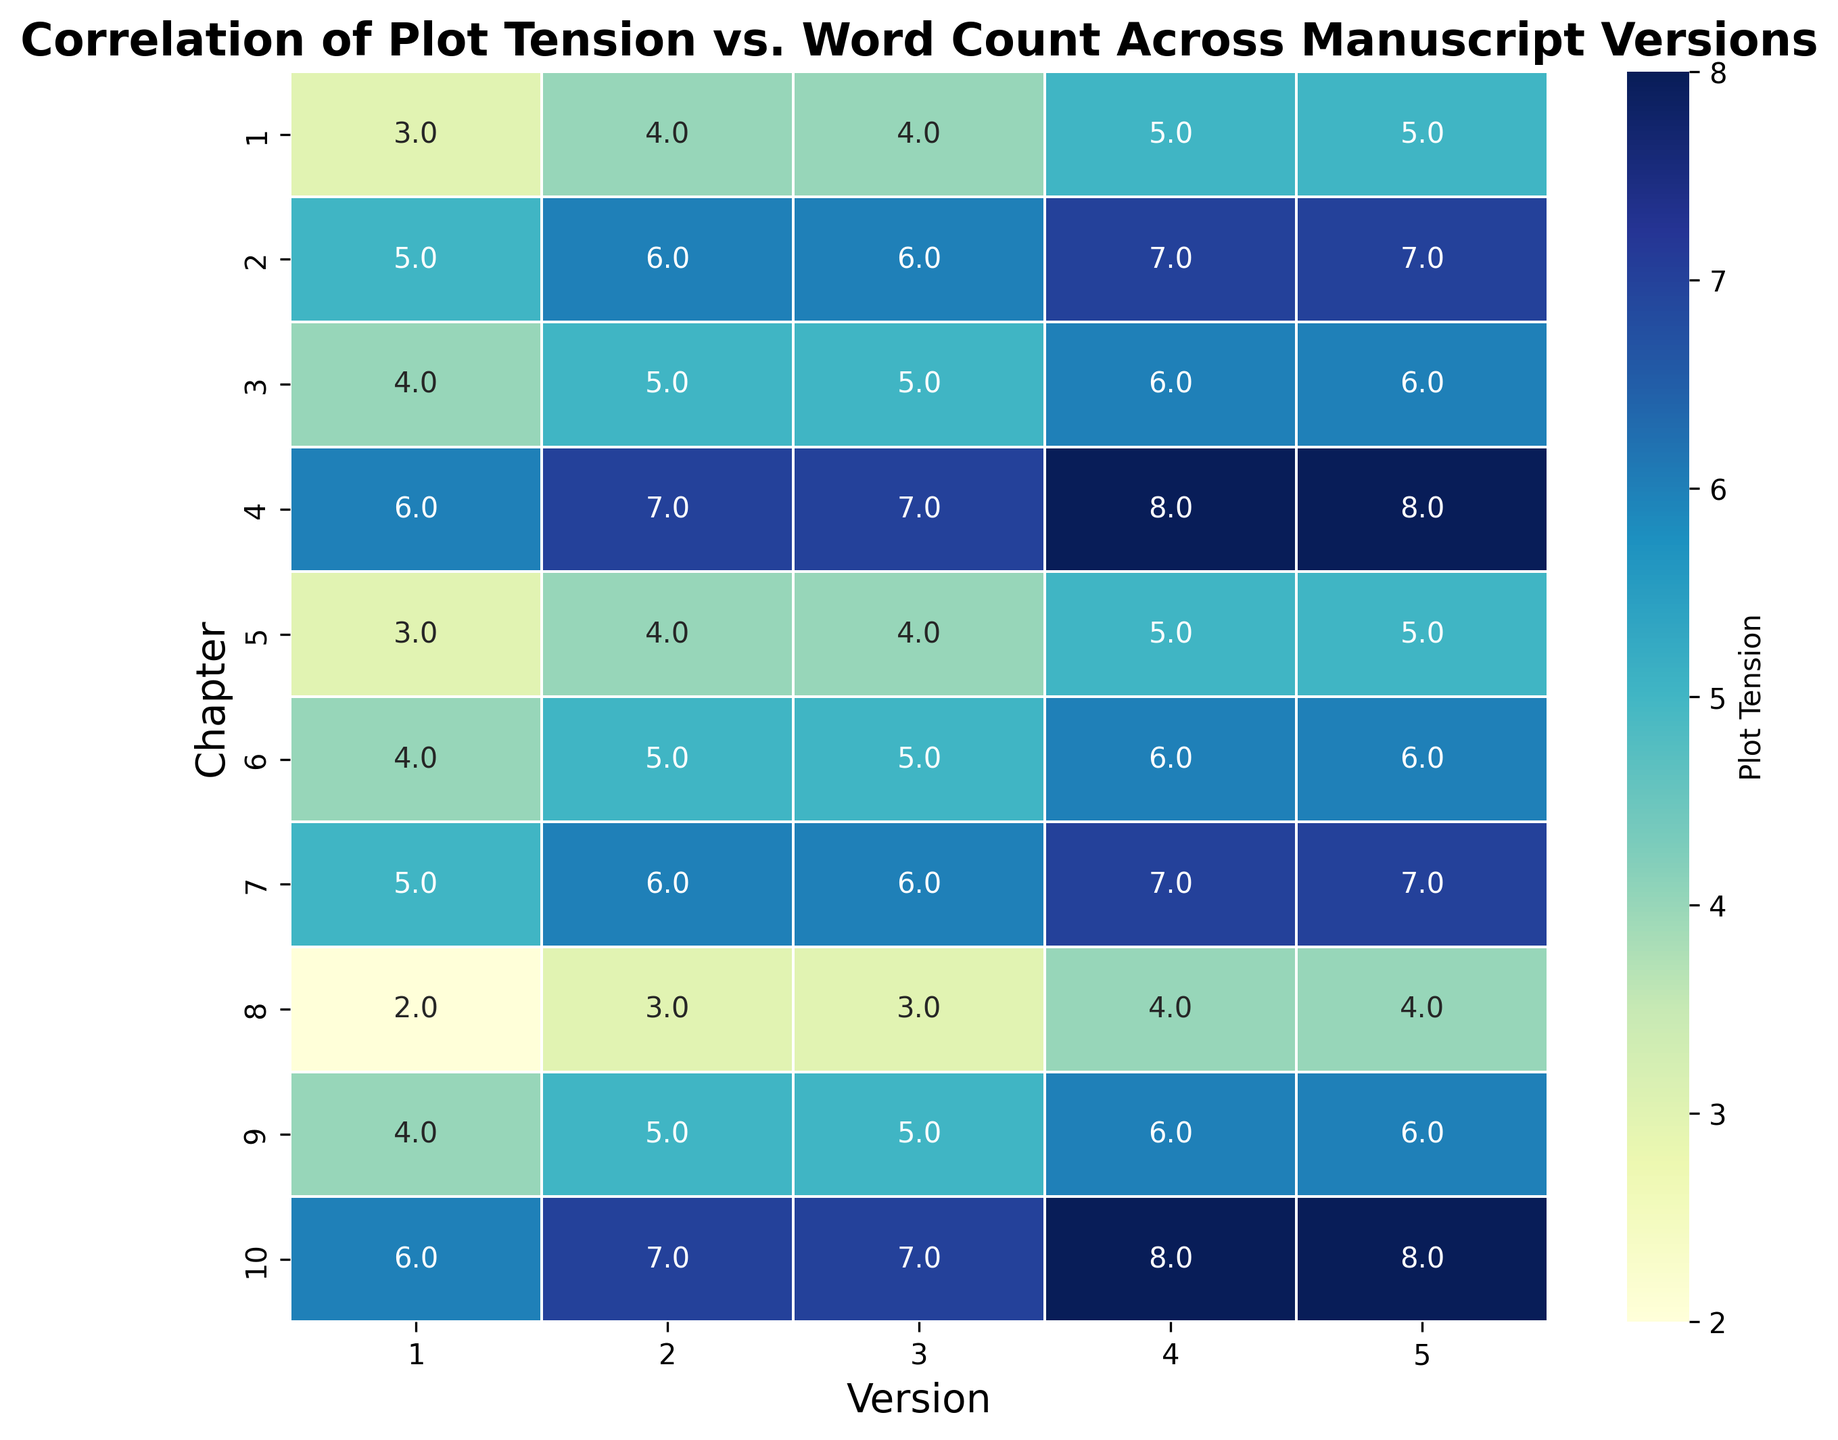Which version has the highest plot tension in Chapter 4? To find this, look at the values in Chapter 4 row and identify the maximum value. For Chapter 4, the highest plot tension is 8 in Version 4 and Version 5.
Answer: Version 4 and Version 5 How does the plot tension in Chapter 1 change across versions? Examine the plot tension values for Chapter 1 across all versions. They are 3, 4, 4, 5, and 5, showing a gradual increase over the versions.
Answer: It increases Is there a chapter where the plot tension remains constant across all versions? If yes, which chapter? Check each chapter's row to see if there is no variation in values across versions. Chapter 10 has consistent values of 6, 7, 7, 8, 8.
Answer: No Which chapter shows the greatest increase in plot tension from Version 1 to Version 5? Find the difference between the plot tensions in Version 1 and Version 5 for each chapter. The largest increase is in Chapter 4, from 6 in Version 1 to 8 in Version 5, an increase of 2.
Answer: Chapter 4 What is the average plot tension value for Chapter 2 across all versions? Sum the plot tension values of Chapter 2 and divide by the number of versions: (5 + 6 + 6 + 7 + 7) / 5 = 6.2
Answer: 6.2 Between which consecutive versions is there the largest average increase in plot tension for Chapter 9? Calculate the pairwise differences between consecutive versions for Chapter 9: 
Version 1 to 2: 5 - 4 = 1
Version 2 to 3: 5 - 5 = 0
Version 3 to 4: 6 - 5 = 1
Version 4 to 5: 6 - 6 = 0
The largest average increase is between Versions 1 and 2 or 3 and 4 (both 1).
Answer: Versions 1 to 2 or 3 to 4 